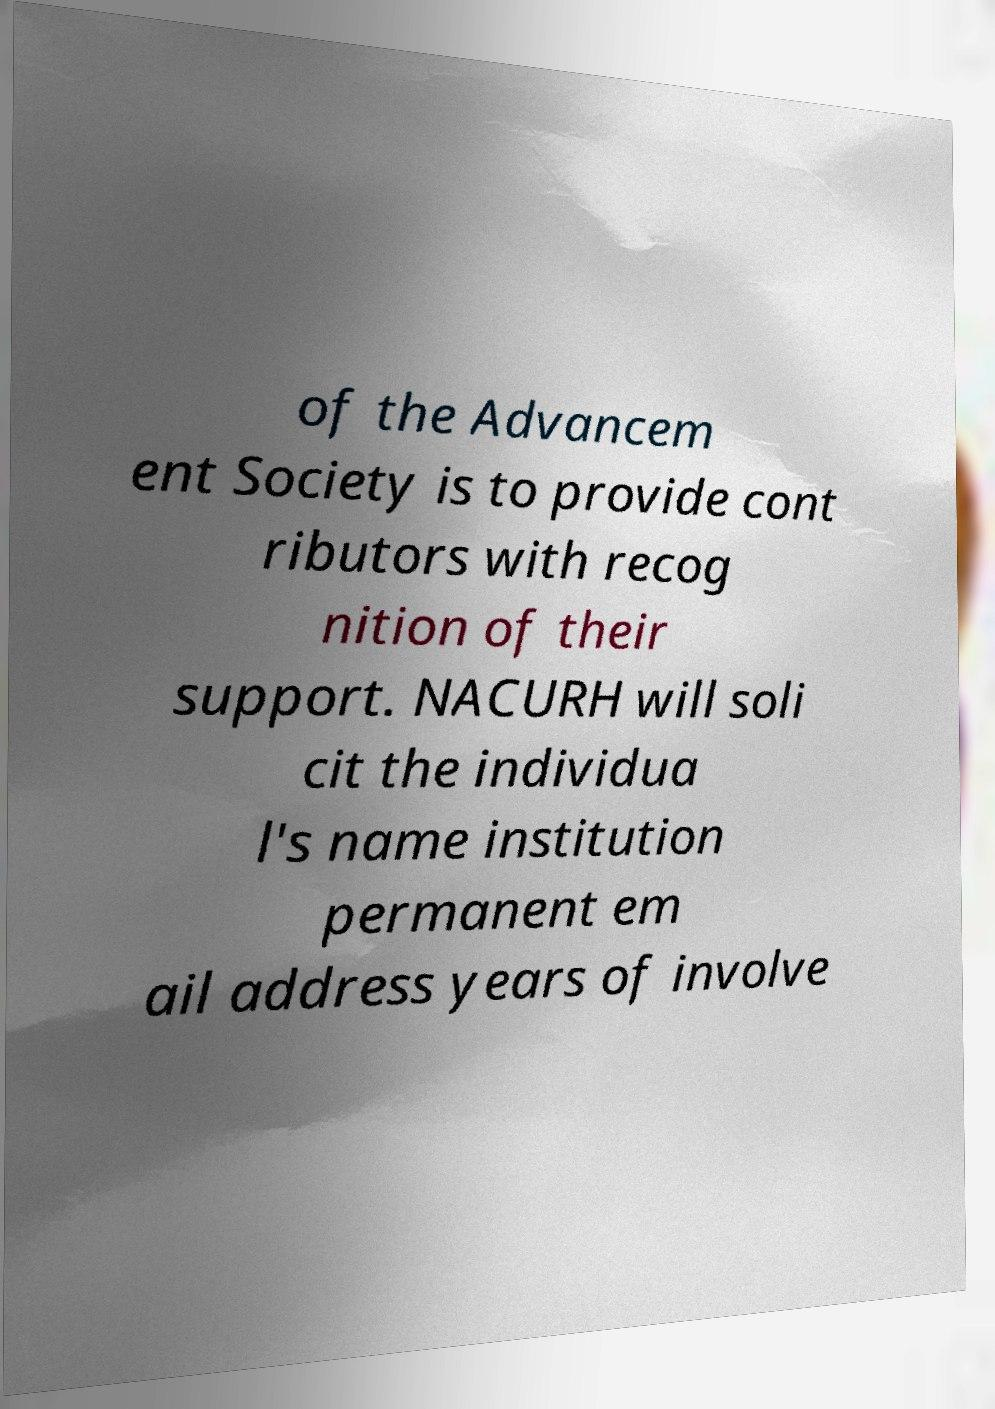What messages or text are displayed in this image? I need them in a readable, typed format. of the Advancem ent Society is to provide cont ributors with recog nition of their support. NACURH will soli cit the individua l's name institution permanent em ail address years of involve 